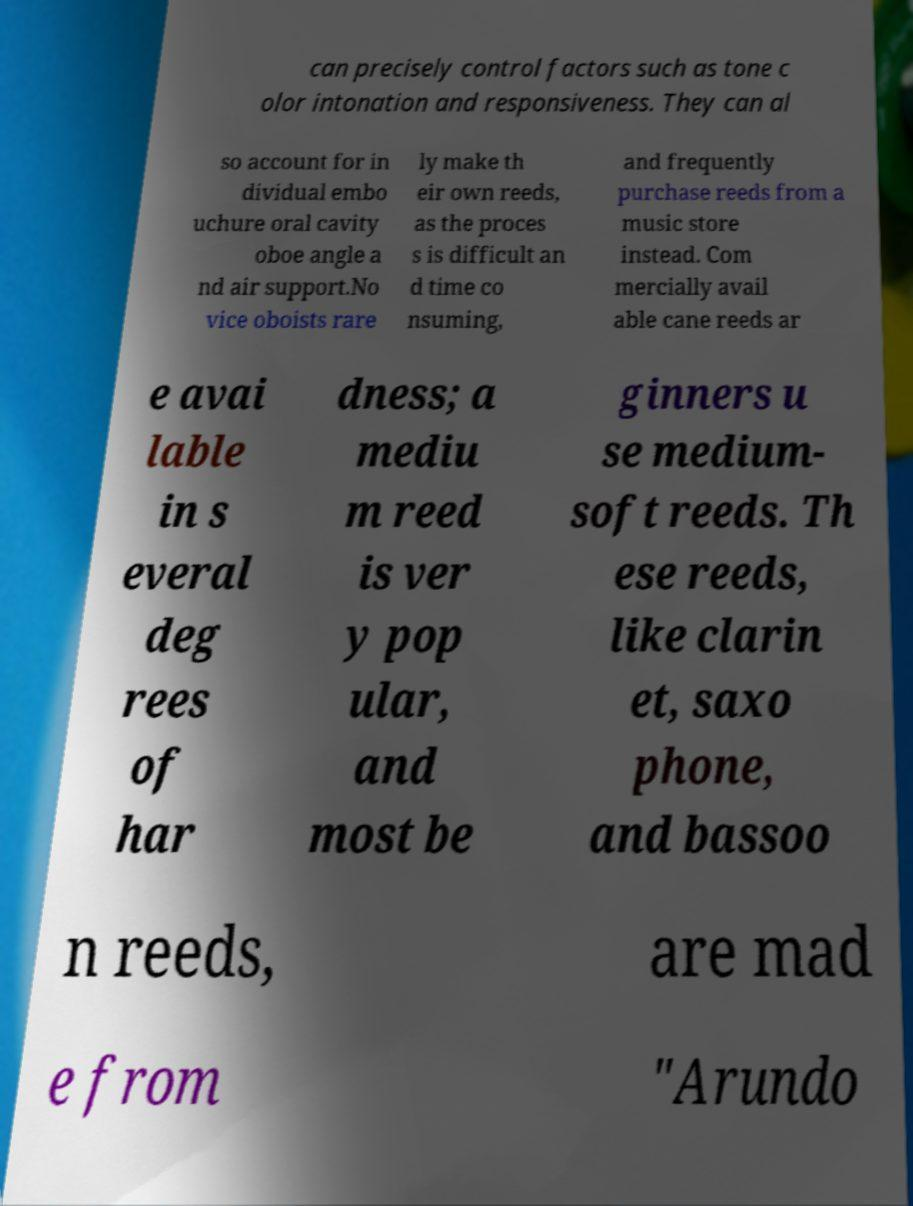Can you accurately transcribe the text from the provided image for me? can precisely control factors such as tone c olor intonation and responsiveness. They can al so account for in dividual embo uchure oral cavity oboe angle a nd air support.No vice oboists rare ly make th eir own reeds, as the proces s is difficult an d time co nsuming, and frequently purchase reeds from a music store instead. Com mercially avail able cane reeds ar e avai lable in s everal deg rees of har dness; a mediu m reed is ver y pop ular, and most be ginners u se medium- soft reeds. Th ese reeds, like clarin et, saxo phone, and bassoo n reeds, are mad e from "Arundo 